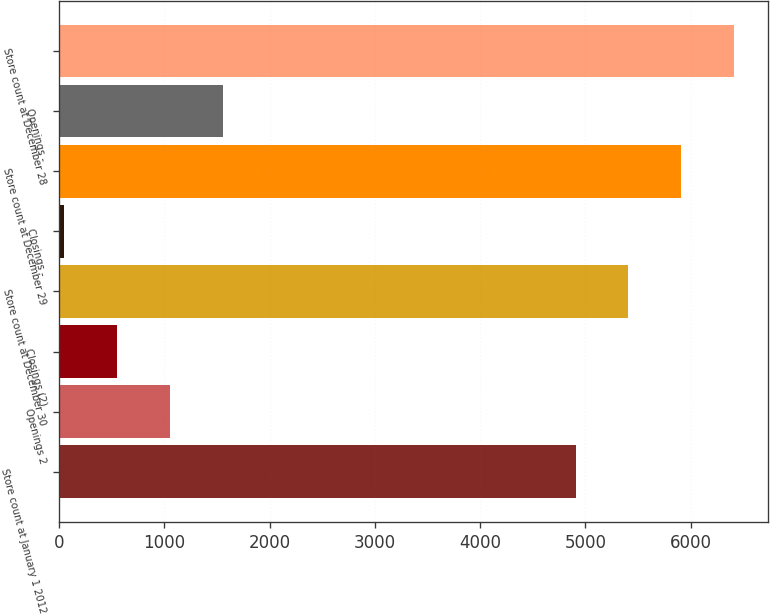Convert chart to OTSL. <chart><loc_0><loc_0><loc_500><loc_500><bar_chart><fcel>Store count at January 1 2012<fcel>Openings 2<fcel>Closings (2)<fcel>Store count at December 30<fcel>Closings -<fcel>Store count at December 29<fcel>Openings -<fcel>Store count at December 28<nl><fcel>4907<fcel>1050.2<fcel>548.1<fcel>5409.1<fcel>46<fcel>5911.2<fcel>1552.3<fcel>6413.3<nl></chart> 